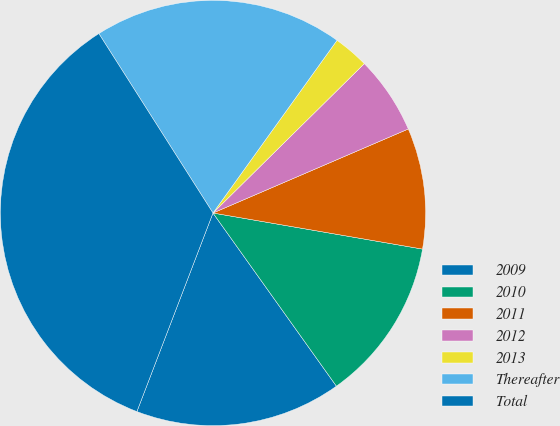Convert chart to OTSL. <chart><loc_0><loc_0><loc_500><loc_500><pie_chart><fcel>2009<fcel>2010<fcel>2011<fcel>2012<fcel>2013<fcel>Thereafter<fcel>Total<nl><fcel>15.68%<fcel>12.43%<fcel>9.18%<fcel>5.93%<fcel>2.69%<fcel>18.93%<fcel>35.16%<nl></chart> 